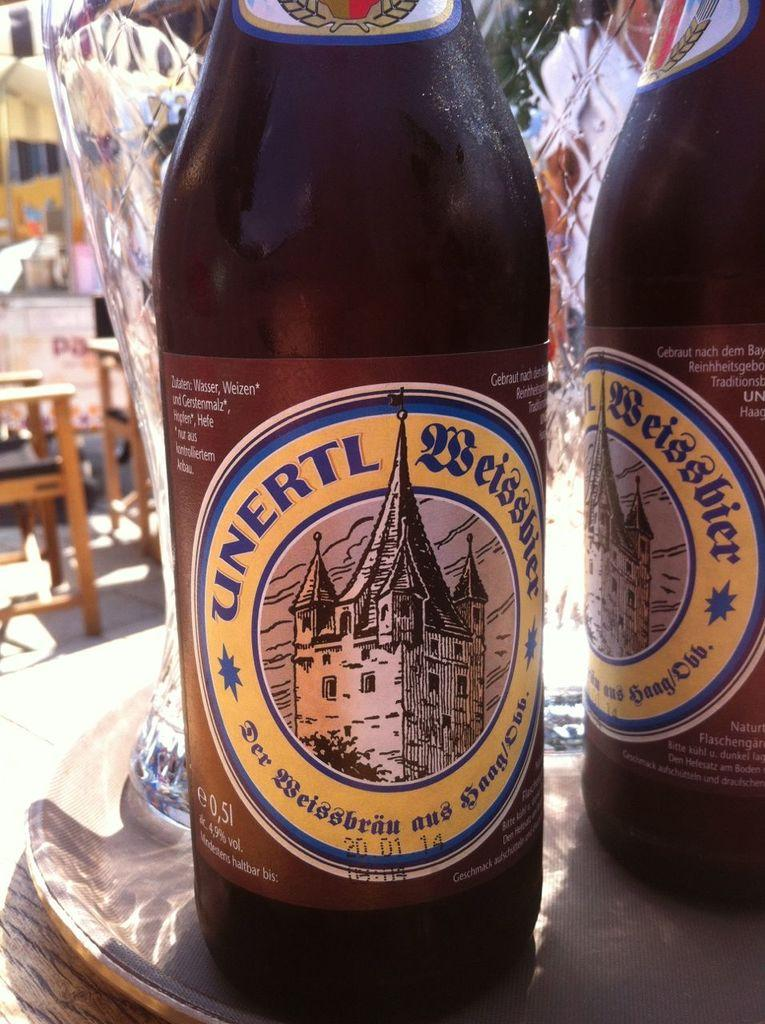<image>
Give a short and clear explanation of the subsequent image. Two bottles of Unertl Beissbier are on a tray outside. 